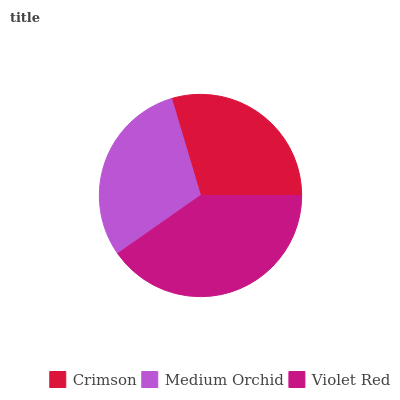Is Crimson the minimum?
Answer yes or no. Yes. Is Violet Red the maximum?
Answer yes or no. Yes. Is Medium Orchid the minimum?
Answer yes or no. No. Is Medium Orchid the maximum?
Answer yes or no. No. Is Medium Orchid greater than Crimson?
Answer yes or no. Yes. Is Crimson less than Medium Orchid?
Answer yes or no. Yes. Is Crimson greater than Medium Orchid?
Answer yes or no. No. Is Medium Orchid less than Crimson?
Answer yes or no. No. Is Medium Orchid the high median?
Answer yes or no. Yes. Is Medium Orchid the low median?
Answer yes or no. Yes. Is Crimson the high median?
Answer yes or no. No. Is Violet Red the low median?
Answer yes or no. No. 